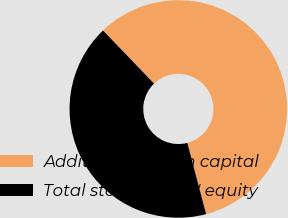Convert chart. <chart><loc_0><loc_0><loc_500><loc_500><pie_chart><fcel>Additional paid-in capital<fcel>Total stockholders' equity<nl><fcel>58.06%<fcel>41.94%<nl></chart> 